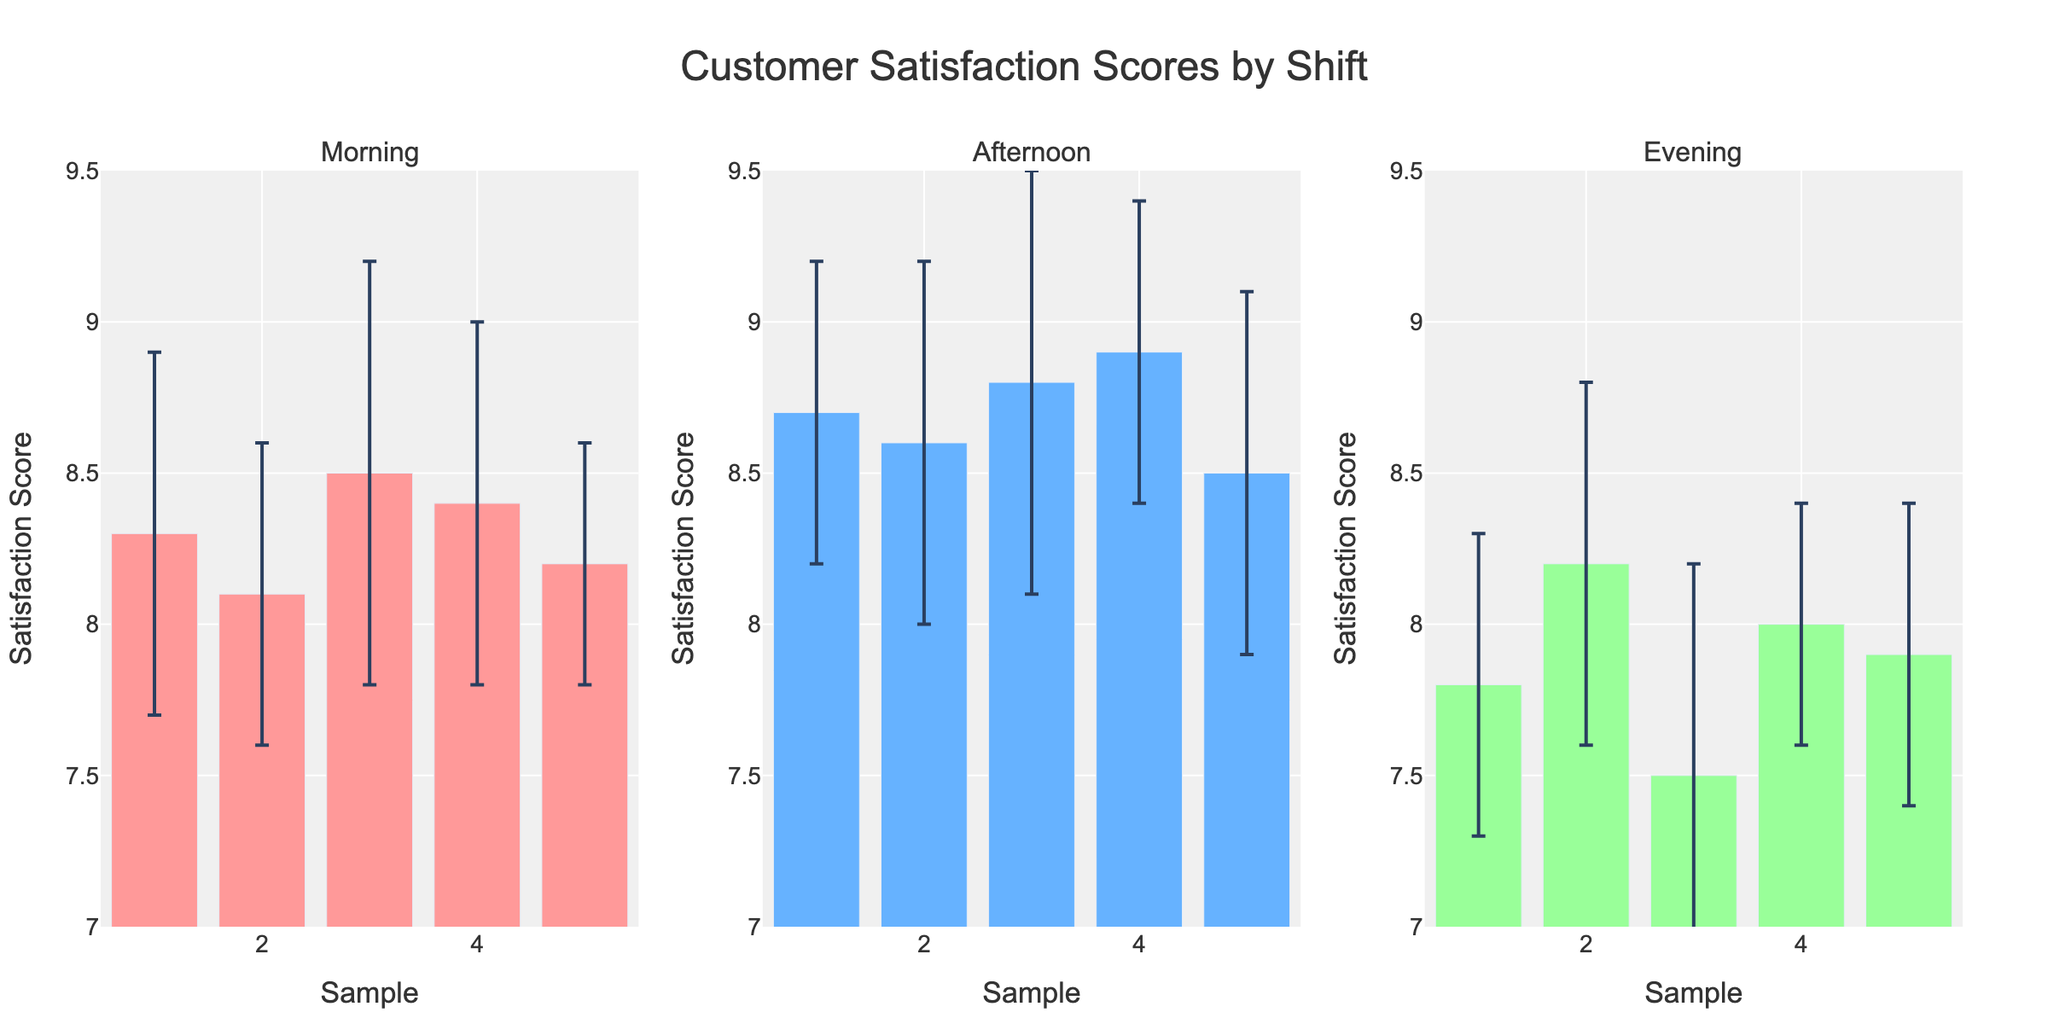Which shift has the highest average customer satisfaction score? By examining the average heights of the bars in all subplots, we see that the evening shift has the highest customer satisfaction scores compared to the other shifts.
Answer: Evening How many data points are there for each shift? By counting the number of bars (data points) in each subplot, we can see there are 5 data points for each shift: Morning, Afternoon, and Evening.
Answer: 5 Which shift has the most variability in customer satisfaction scores? The variability can be seen from the error bars' length. By comparing the error bars across all subplots, the Evening shift seems to have more significant variability, indicated by larger error bars.
Answer: Evening What is the range of customer satisfaction scores for the morning shift? We look at the highest and lowest bars in the Morning subplot. The highest score is around 8.2, and the lowest is about 7.5. Thus, the range is 8.2 - 7.5 = 0.7.
Answer: 0.7 Is there any overlap in the error bars for the different shifts, suggesting common customer satisfaction levels? By visually inspecting the error bars in each subplot, we can see that there are overlaps, especially in the Afternoon and Evening shifts suggesting some common satisfaction levels amongst them.
Answer: Yes Which shift's customer satisfaction scores are closest to each other on average? We can compare the clusters of bars in each subplot. The Afternoon shift has bars (scores) that are relatively close to each other, implying less variability.
Answer: Afternoon What is the maximum customer satisfaction score recorded, including error bars? The highest satisfaction score is in the Evening shift, with the bar around 8.9. Considering the error bars, which can reach up to 0.7, the maximum could be approximately 8.9 + 0.7 = 9.6.
Answer: 9.6 Which shift has the smallest error bar on average? By comparing the lengths of the error bars within each subplot, the Morning shift has generally smaller error bars compared to the other two shifts.
Answer: Morning 